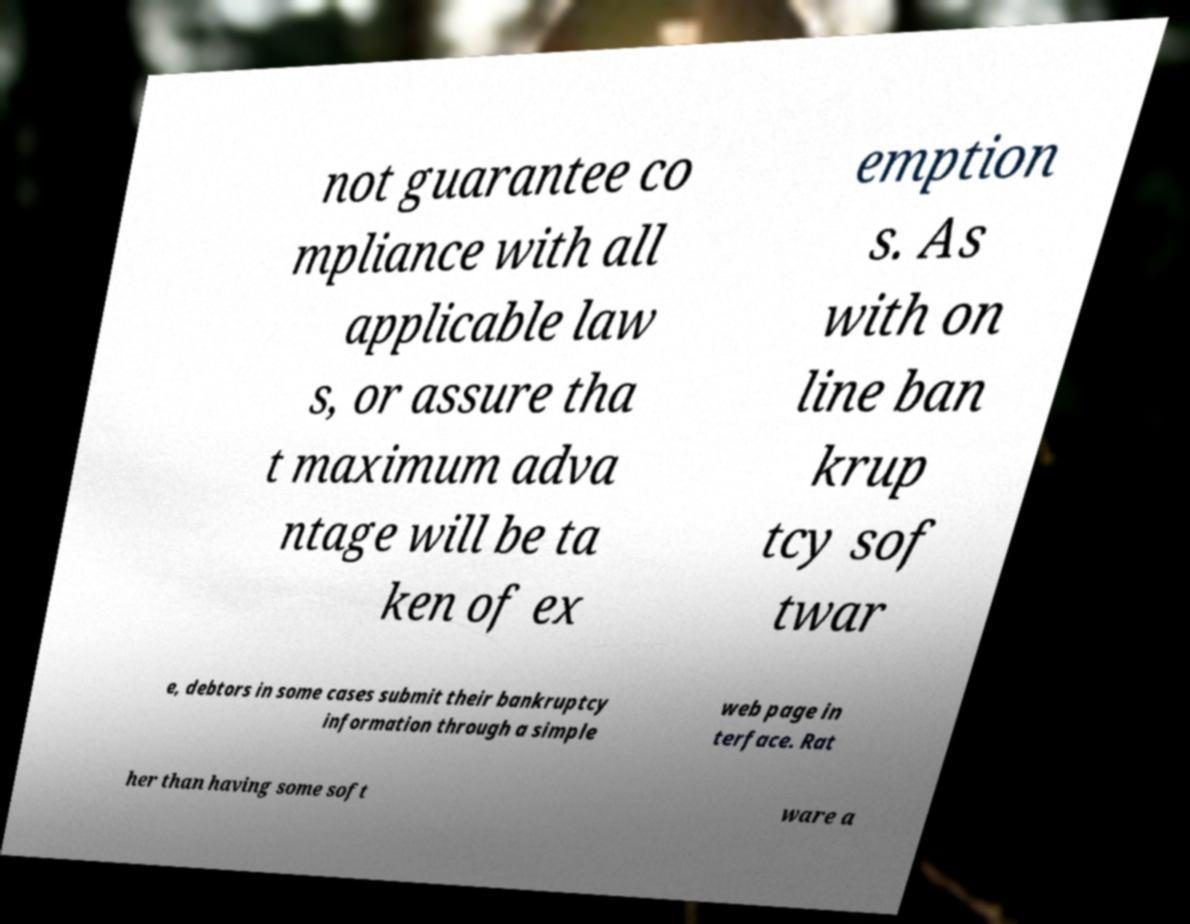Could you extract and type out the text from this image? not guarantee co mpliance with all applicable law s, or assure tha t maximum adva ntage will be ta ken of ex emption s. As with on line ban krup tcy sof twar e, debtors in some cases submit their bankruptcy information through a simple web page in terface. Rat her than having some soft ware a 